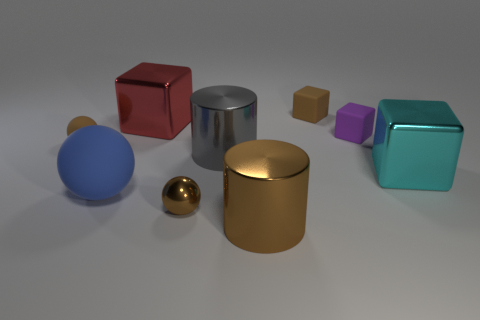What color is the block that is on the left side of the small metal object?
Keep it short and to the point. Red. There is a metal thing in front of the tiny brown ball to the right of the large blue object; what shape is it?
Provide a short and direct response. Cylinder. Does the shiny ball have the same color as the small rubber ball?
Keep it short and to the point. Yes. How many cylinders are either large objects or large gray shiny things?
Give a very brief answer. 2. What is the material of the object that is both in front of the gray metallic thing and right of the brown cylinder?
Ensure brevity in your answer.  Metal. How many purple blocks are right of the gray metal cylinder?
Offer a terse response. 1. Is the large cube right of the large gray shiny thing made of the same material as the sphere on the left side of the big blue thing?
Offer a very short reply. No. What number of objects are rubber things that are on the left side of the big matte ball or big gray matte blocks?
Make the answer very short. 1. Is the number of large red metal objects in front of the big brown cylinder less than the number of large metal things in front of the red block?
Give a very brief answer. Yes. What number of other objects are the same size as the cyan metal object?
Make the answer very short. 4. 